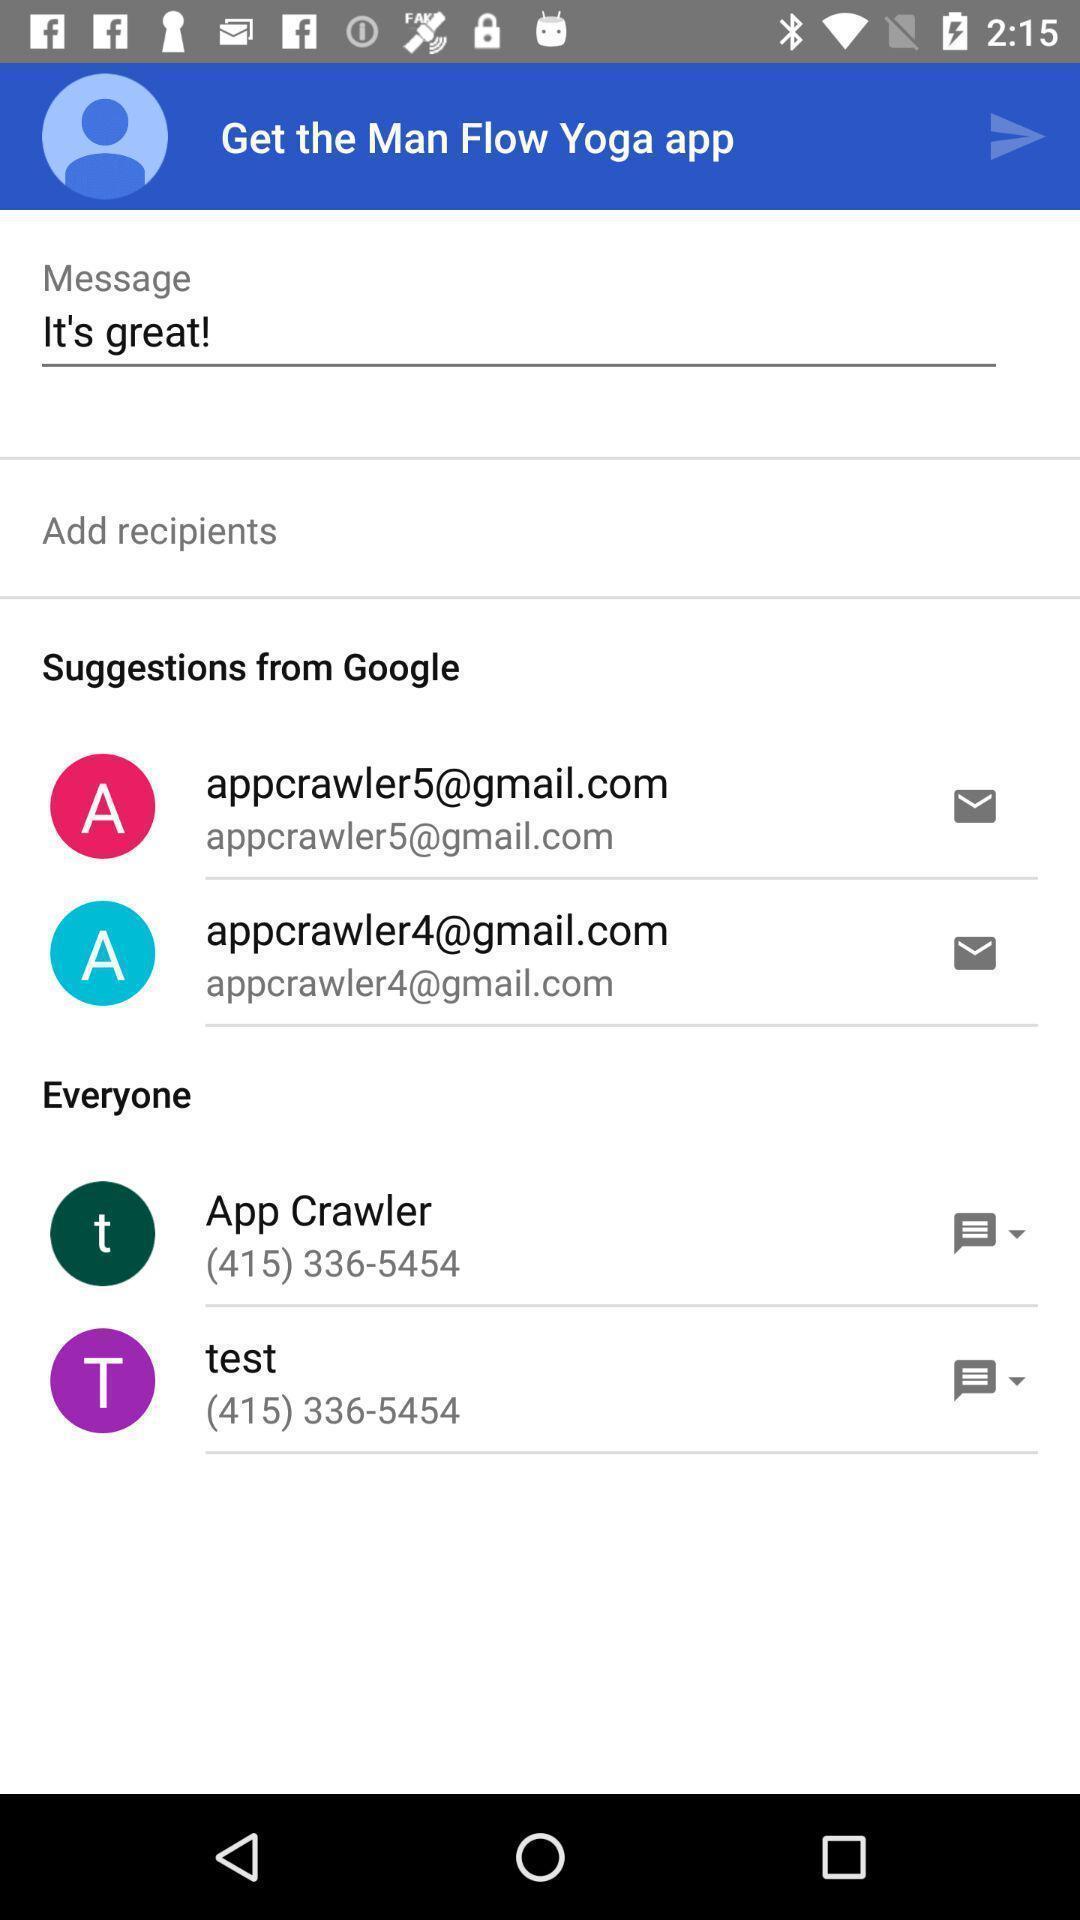Summarize the main components in this picture. Text messaging bar in a yoga app. 